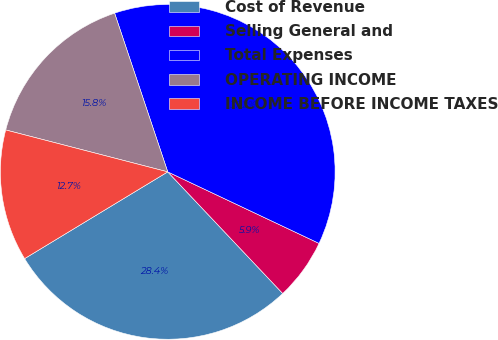Convert chart to OTSL. <chart><loc_0><loc_0><loc_500><loc_500><pie_chart><fcel>Cost of Revenue<fcel>Selling General and<fcel>Total Expenses<fcel>OPERATING INCOME<fcel>INCOME BEFORE INCOME TAXES<nl><fcel>28.38%<fcel>5.92%<fcel>37.17%<fcel>15.83%<fcel>12.7%<nl></chart> 